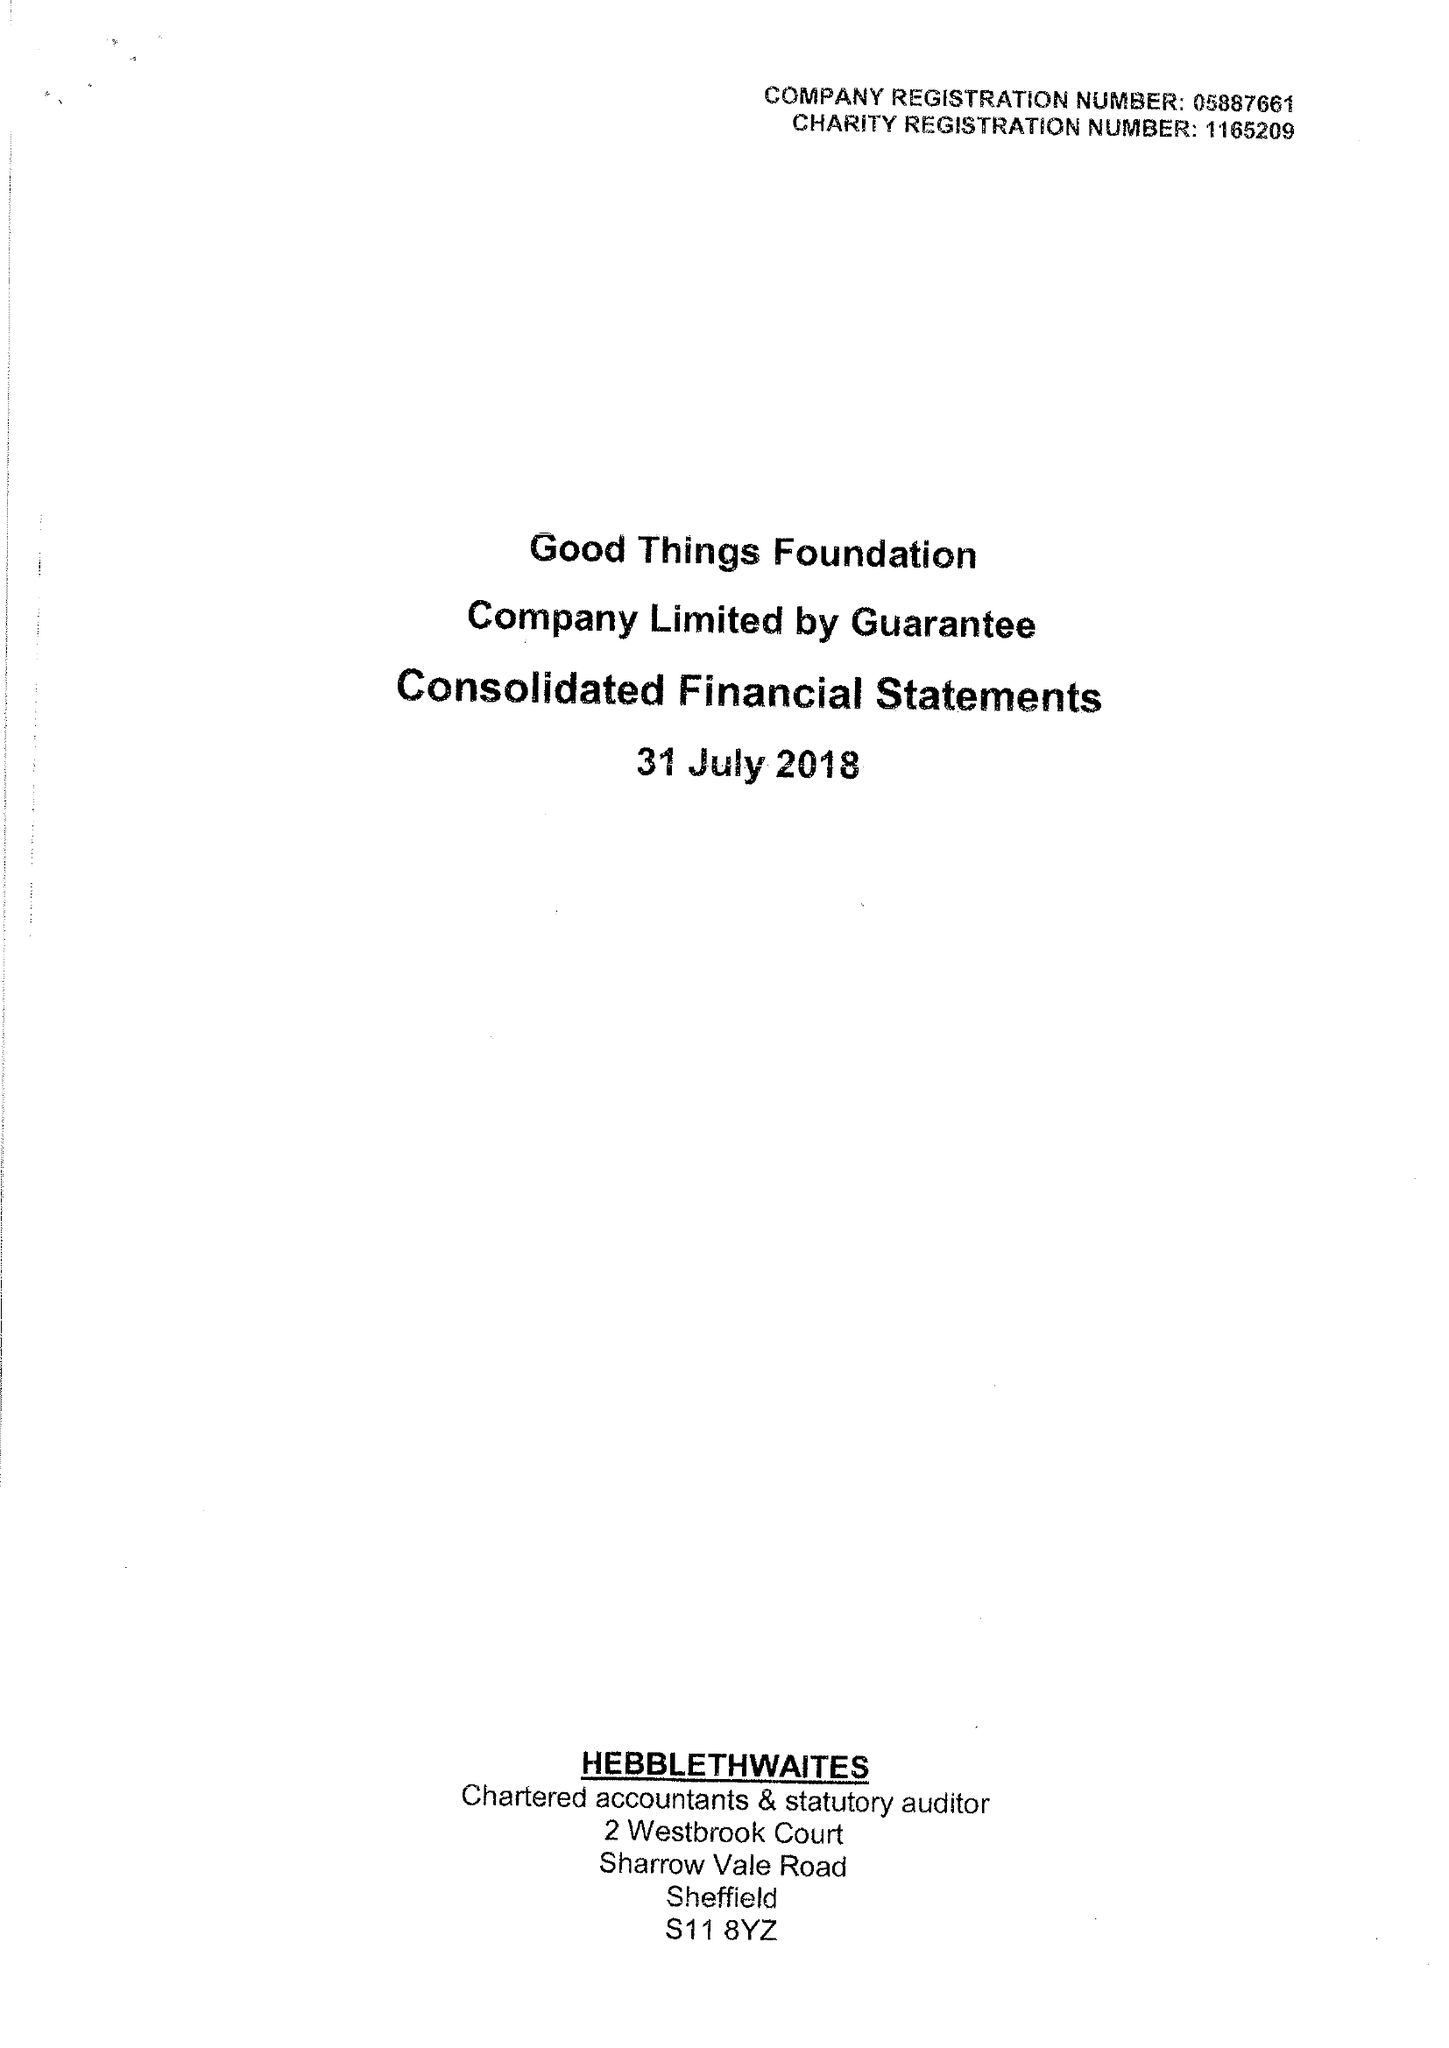What is the value for the income_annually_in_british_pounds?
Answer the question using a single word or phrase. 10667114.00 